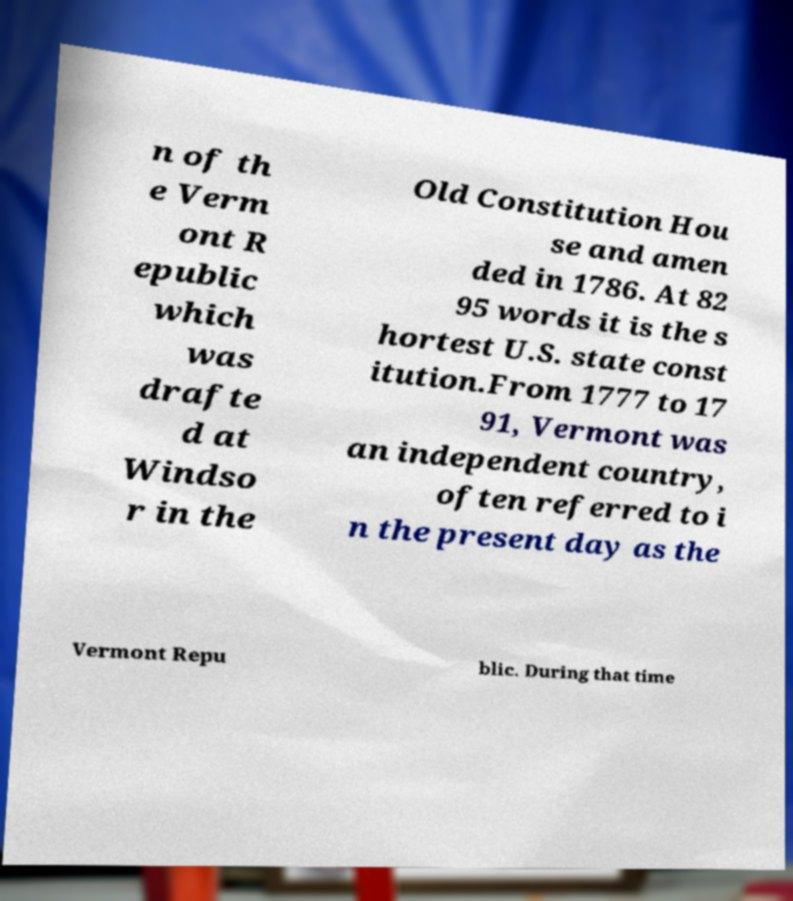Please identify and transcribe the text found in this image. n of th e Verm ont R epublic which was drafte d at Windso r in the Old Constitution Hou se and amen ded in 1786. At 82 95 words it is the s hortest U.S. state const itution.From 1777 to 17 91, Vermont was an independent country, often referred to i n the present day as the Vermont Repu blic. During that time 